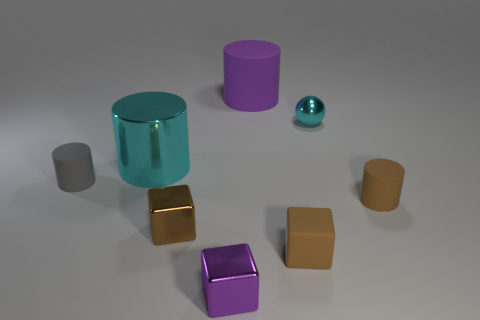Add 1 small red metallic cubes. How many objects exist? 9 Subtract all blocks. How many objects are left? 5 Subtract 0 blue cylinders. How many objects are left? 8 Subtract all gray objects. Subtract all small brown metal objects. How many objects are left? 6 Add 8 cyan metal balls. How many cyan metal balls are left? 9 Add 1 tiny purple metallic cubes. How many tiny purple metallic cubes exist? 2 